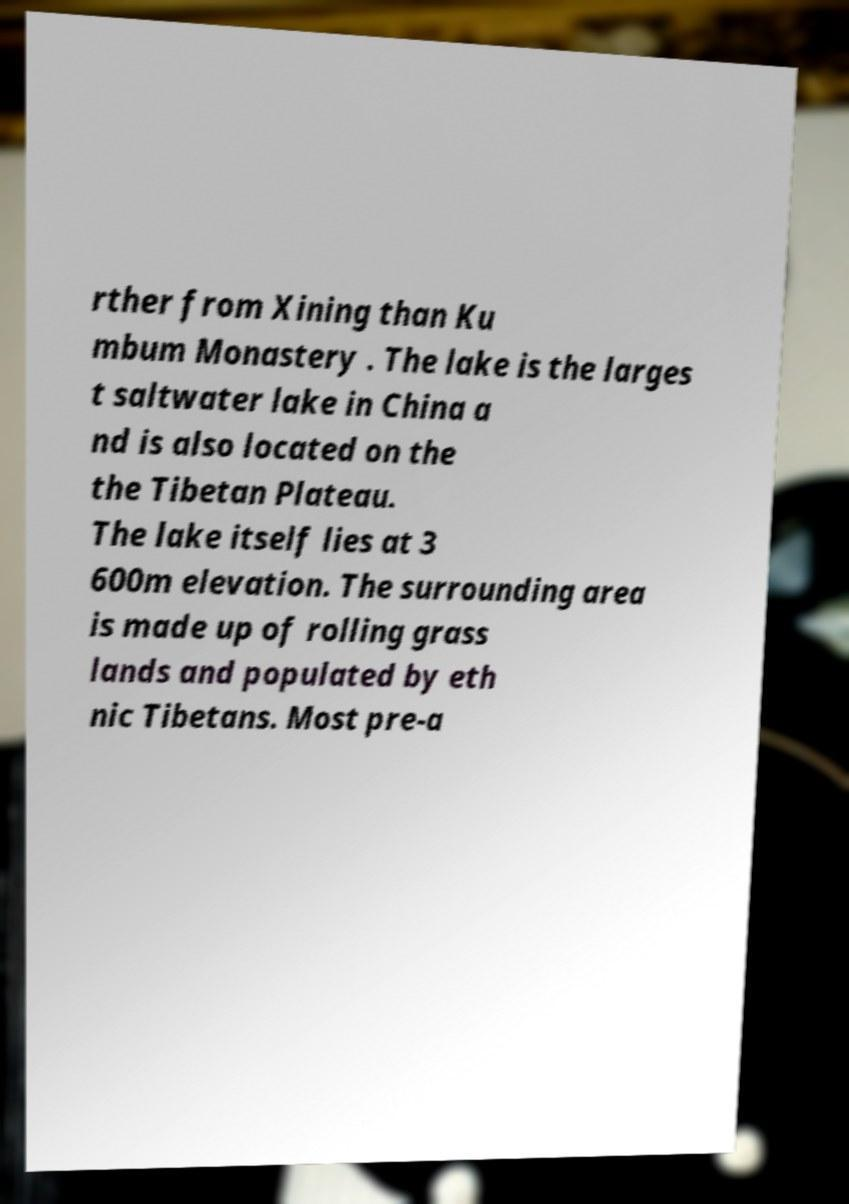Could you extract and type out the text from this image? rther from Xining than Ku mbum Monastery . The lake is the larges t saltwater lake in China a nd is also located on the the Tibetan Plateau. The lake itself lies at 3 600m elevation. The surrounding area is made up of rolling grass lands and populated by eth nic Tibetans. Most pre-a 